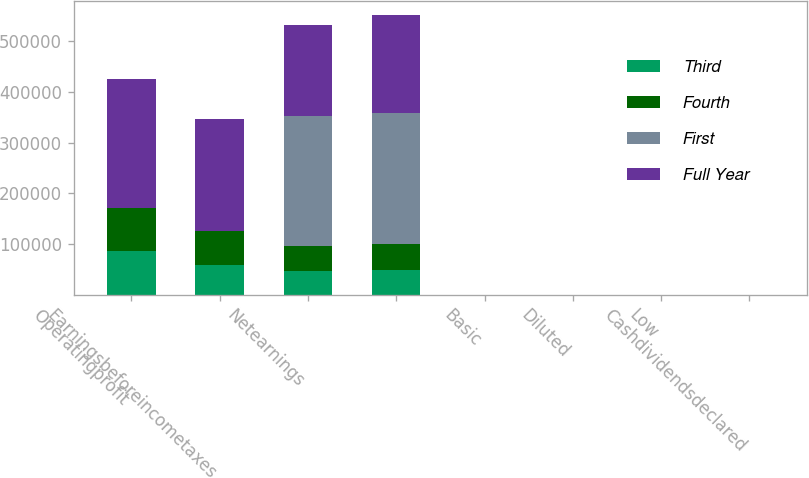Convert chart to OTSL. <chart><loc_0><loc_0><loc_500><loc_500><stacked_bar_chart><ecel><fcel>Operatingprofit<fcel>Earningsbeforeincometaxes<fcel>Netearnings<fcel>Unnamed: 4<fcel>Basic<fcel>Diluted<fcel>Low<fcel>Cashdividendsdeclared<nl><fcel>Third<fcel>85916<fcel>59213<fcel>46971<fcel>48751<fcel>0.39<fcel>0.38<fcel>66.96<fcel>0.51<nl><fcel>Fourth<fcel>84874<fcel>67020<fcel>49419<fcel>52106<fcel>0.42<fcel>0.41<fcel>77.8<fcel>0.51<nl><fcel>First<fcel>77.535<fcel>77.535<fcel>256162<fcel>257798<fcel>2.05<fcel>2.03<fcel>76.16<fcel>0.51<nl><fcel>Full Year<fcel>255157<fcel>219932<fcel>180599<fcel>192725<fcel>1.54<fcel>1.52<fcel>77.27<fcel>0.51<nl></chart> 